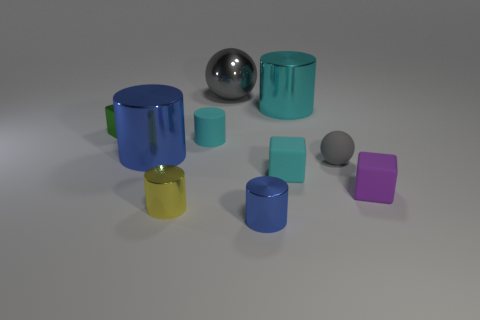Imagine if these objects were part of a still life painting. What kind of story could they tell? If these objects were part of a still life painting, they could convey a narrative of harmony and balance through their orderly placement and the pleasing combination of colors. Each object could symbolize different elements—cylinders representing pillars of strength, the sphere signifying wholeness and unity, and the mug perhaps indicating a human presence or domesticity. The scene could invoke a contemplation of the simple yet intrinsic beauty of geometric forms that we encounter in everyday life. 